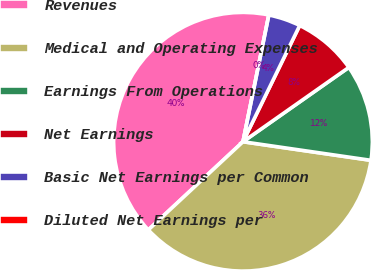<chart> <loc_0><loc_0><loc_500><loc_500><pie_chart><fcel>Revenues<fcel>Medical and Operating Expenses<fcel>Earnings From Operations<fcel>Net Earnings<fcel>Basic Net Earnings per Common<fcel>Diluted Net Earnings per<nl><fcel>40.13%<fcel>35.77%<fcel>12.04%<fcel>8.03%<fcel>4.02%<fcel>0.0%<nl></chart> 